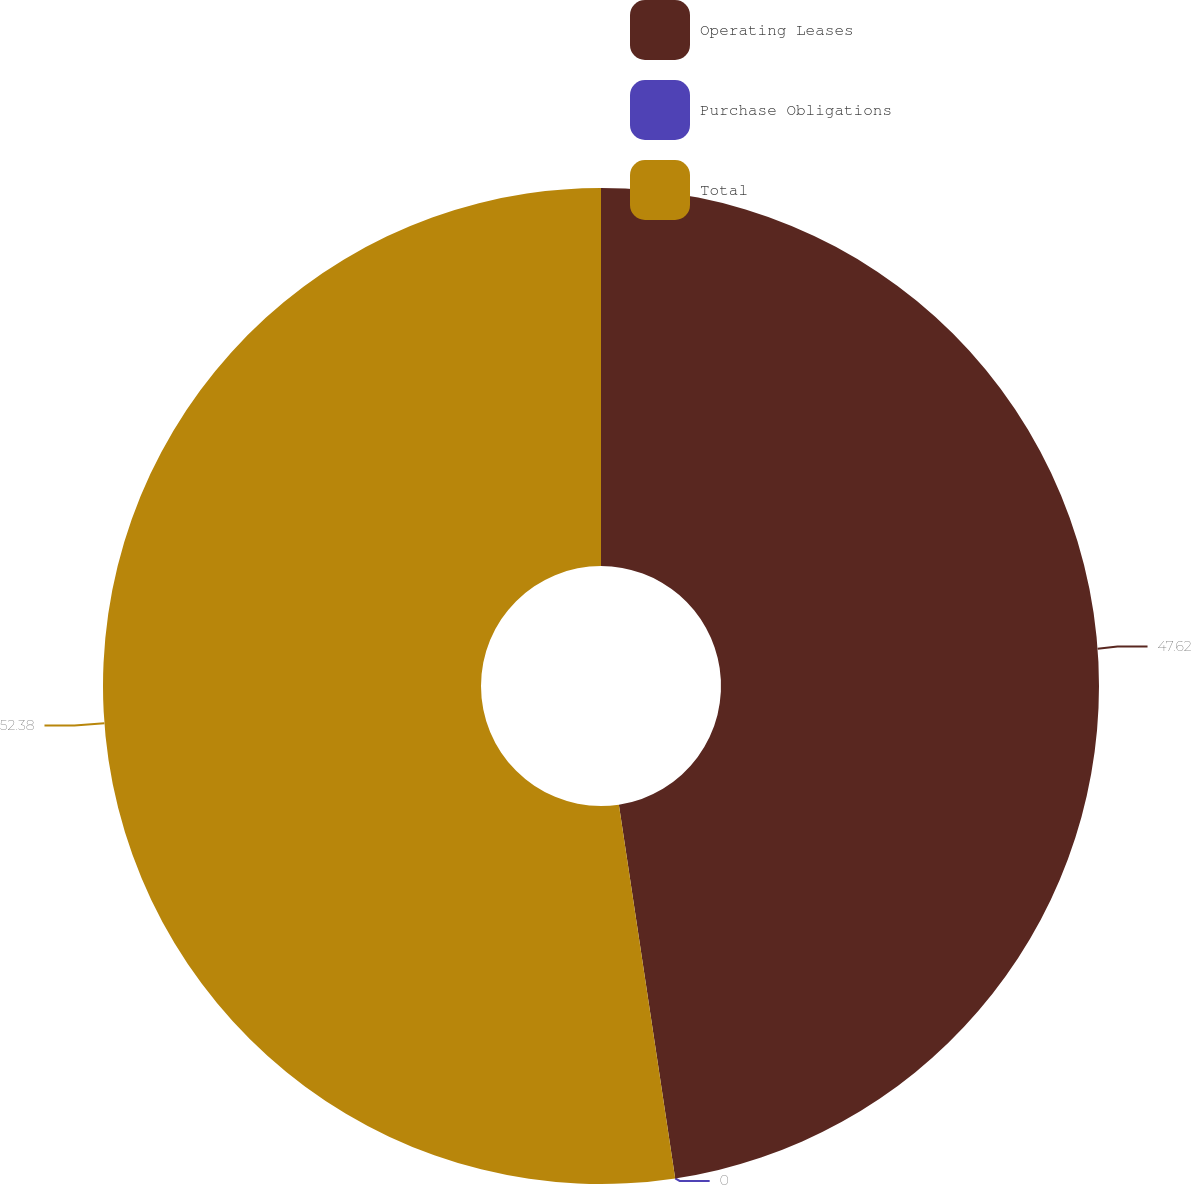<chart> <loc_0><loc_0><loc_500><loc_500><pie_chart><fcel>Operating Leases<fcel>Purchase Obligations<fcel>Total<nl><fcel>47.62%<fcel>0.0%<fcel>52.38%<nl></chart> 